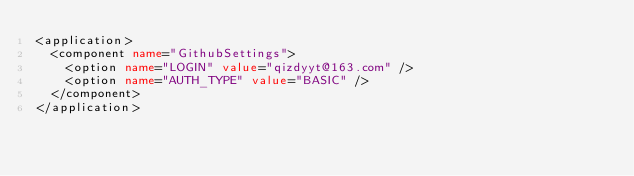<code> <loc_0><loc_0><loc_500><loc_500><_XML_><application>
  <component name="GithubSettings">
    <option name="LOGIN" value="qizdyyt@163.com" />
    <option name="AUTH_TYPE" value="BASIC" />
  </component>
</application></code> 